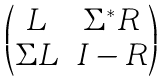Convert formula to latex. <formula><loc_0><loc_0><loc_500><loc_500>\begin{pmatrix} L & \Sigma ^ { * } R \\ \Sigma L & I - R \end{pmatrix}</formula> 